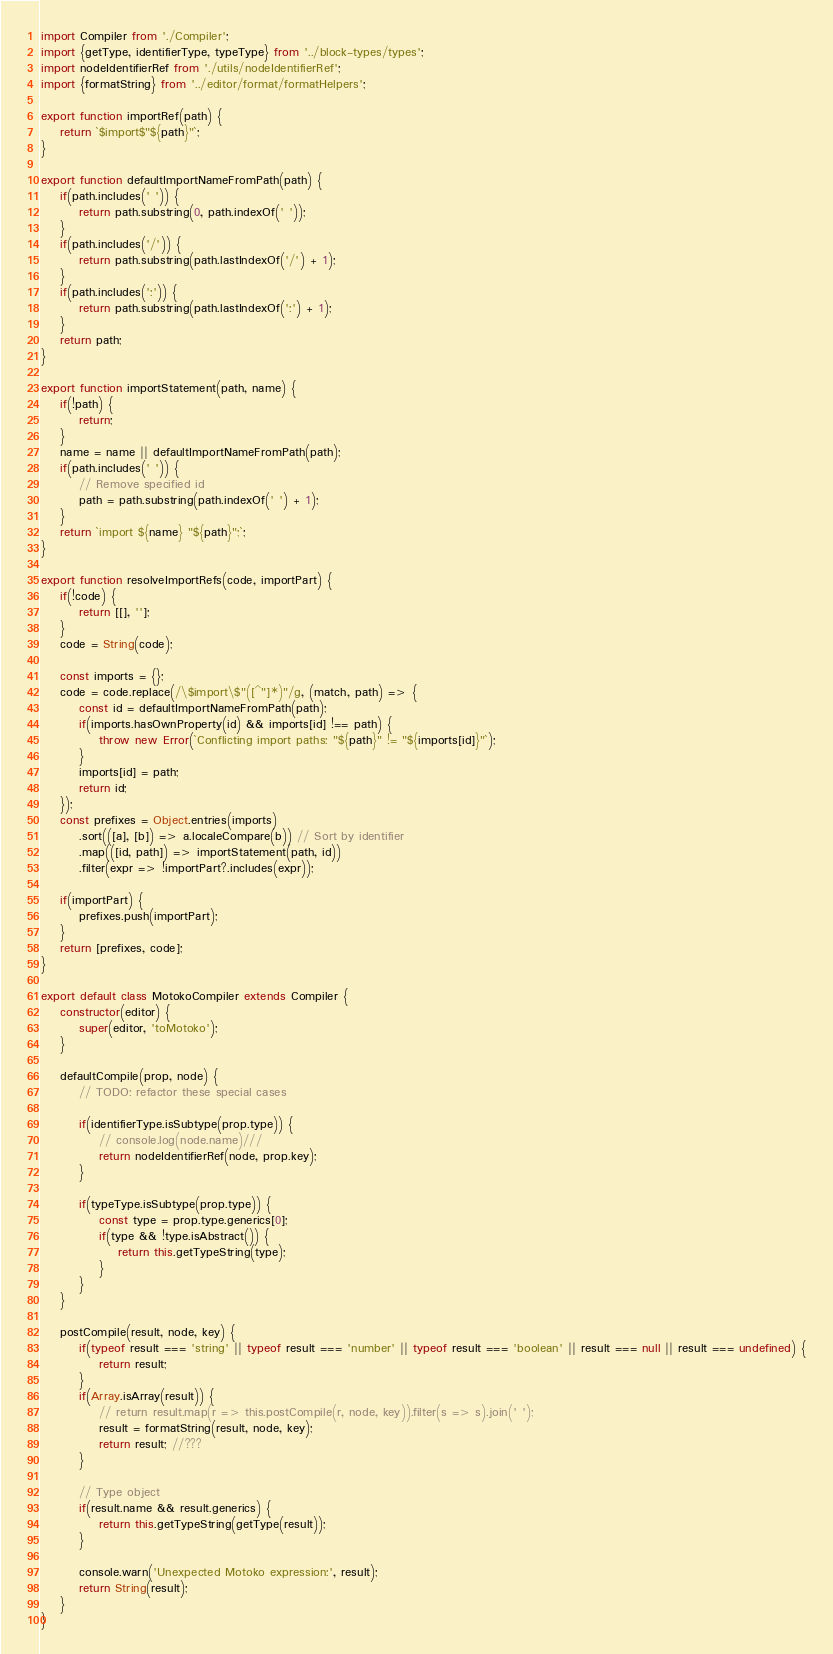<code> <loc_0><loc_0><loc_500><loc_500><_JavaScript_>import Compiler from './Compiler';
import {getType, identifierType, typeType} from '../block-types/types';
import nodeIdentifierRef from './utils/nodeIdentifierRef';
import {formatString} from '../editor/format/formatHelpers';

export function importRef(path) {
    return `$import$"${path}"`;
}

export function defaultImportNameFromPath(path) {
    if(path.includes(' ')) {
        return path.substring(0, path.indexOf(' '));
    }
    if(path.includes('/')) {
        return path.substring(path.lastIndexOf('/') + 1);
    }
    if(path.includes(':')) {
        return path.substring(path.lastIndexOf(':') + 1);
    }
    return path;
}

export function importStatement(path, name) {
    if(!path) {
        return;
    }
    name = name || defaultImportNameFromPath(path);
    if(path.includes(' ')) {
        // Remove specified id
        path = path.substring(path.indexOf(' ') + 1);
    }
    return `import ${name} "${path}";`;
}

export function resolveImportRefs(code, importPart) {
    if(!code) {
        return [[], ''];
    }
    code = String(code);

    const imports = {};
    code = code.replace(/\$import\$"([^"]*)"/g, (match, path) => {
        const id = defaultImportNameFromPath(path);
        if(imports.hasOwnProperty(id) && imports[id] !== path) {
            throw new Error(`Conflicting import paths: "${path}" != "${imports[id]}"`);
        }
        imports[id] = path;
        return id;
    });
    const prefixes = Object.entries(imports)
        .sort(([a], [b]) => a.localeCompare(b)) // Sort by identifier
        .map(([id, path]) => importStatement(path, id))
        .filter(expr => !importPart?.includes(expr));

    if(importPart) {
        prefixes.push(importPart);
    }
    return [prefixes, code];
}

export default class MotokoCompiler extends Compiler {
    constructor(editor) {
        super(editor, 'toMotoko');
    }

    defaultCompile(prop, node) {
        // TODO: refactor these special cases

        if(identifierType.isSubtype(prop.type)) {
            // console.log(node.name)///
            return nodeIdentifierRef(node, prop.key);
        }

        if(typeType.isSubtype(prop.type)) {
            const type = prop.type.generics[0];
            if(type && !type.isAbstract()) {
                return this.getTypeString(type);
            }
        }
    }

    postCompile(result, node, key) {
        if(typeof result === 'string' || typeof result === 'number' || typeof result === 'boolean' || result === null || result === undefined) {
            return result;
        }
        if(Array.isArray(result)) {
            // return result.map(r => this.postCompile(r, node, key)).filter(s => s).join(' ');
            result = formatString(result, node, key);
            return result; //???
        }

        // Type object
        if(result.name && result.generics) {
            return this.getTypeString(getType(result));
        }

        console.warn('Unexpected Motoko expression:', result);
        return String(result);
    }
}</code> 